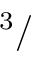<formula> <loc_0><loc_0><loc_500><loc_500>{ ^ { 3 } } /</formula> 